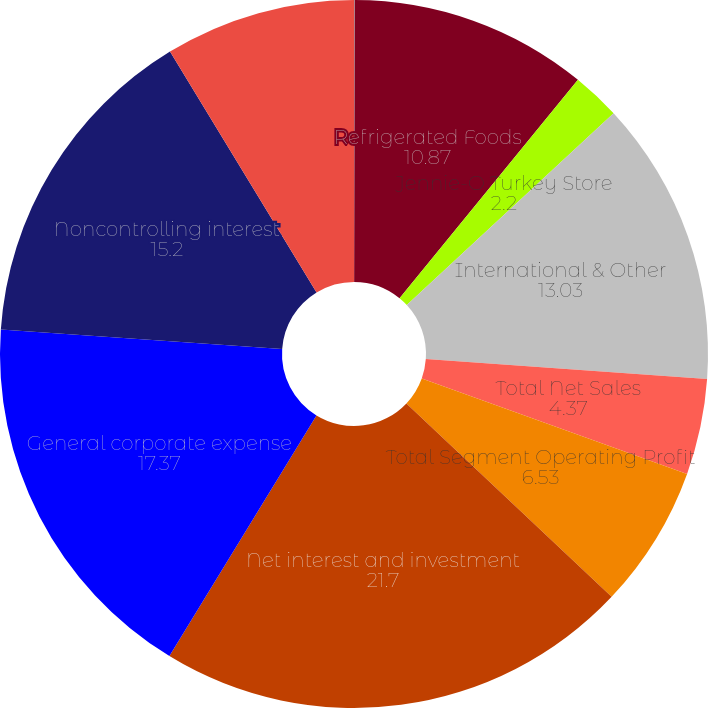<chart> <loc_0><loc_0><loc_500><loc_500><pie_chart><fcel>Grocery Products<fcel>Refrigerated Foods<fcel>Jennie-O Turkey Store<fcel>International & Other<fcel>Total Net Sales<fcel>Total Segment Operating Profit<fcel>Net interest and investment<fcel>General corporate expense<fcel>Noncontrolling interest<fcel>Earnings Before Income Taxes<nl><fcel>0.03%<fcel>10.87%<fcel>2.2%<fcel>13.03%<fcel>4.37%<fcel>6.53%<fcel>21.7%<fcel>17.37%<fcel>15.2%<fcel>8.7%<nl></chart> 